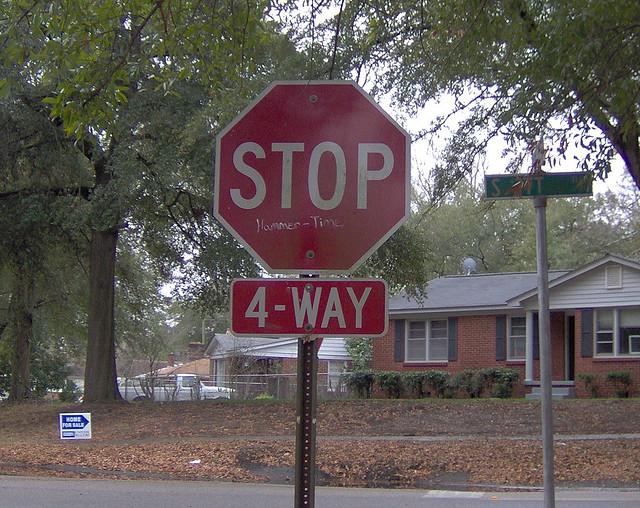Where is graffiti written?
Keep it brief. Stop sign. Is the grass healthy or dying in the photograph?
Be succinct. Dying. What color is the building in the background?
Give a very brief answer. Brown. What should oncoming traffic do?
Short answer required. Stop. How many lanes have to stop?
Answer briefly. 4. What type of tree is shown?
Quick response, please. Oak. 